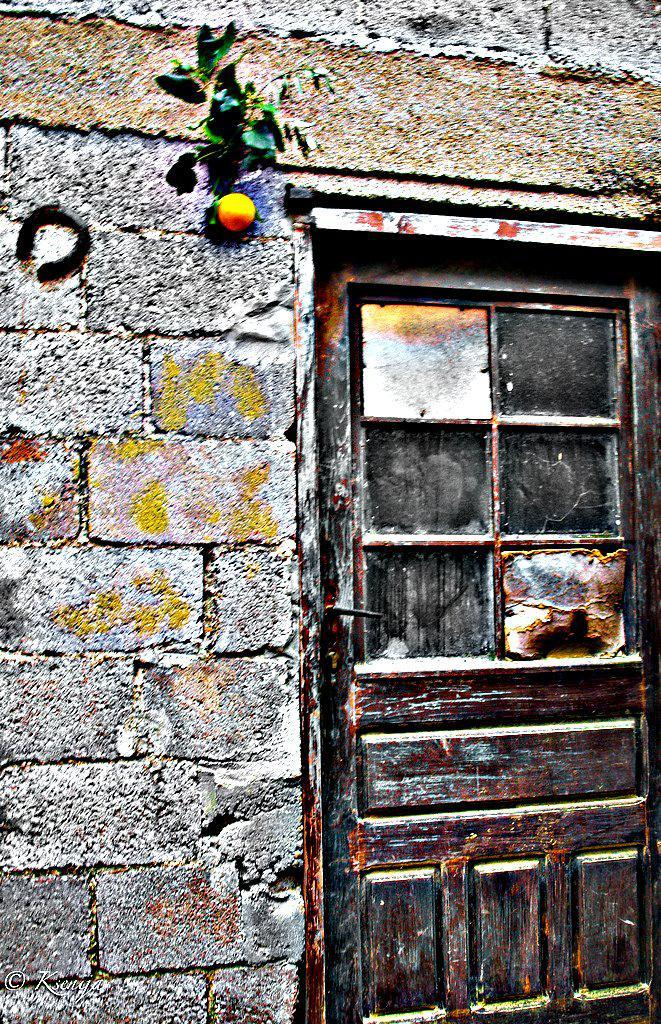What type of door is on the right side of the image? There is a wooden door on the right side of the image. What can be seen in the image besides the door? There are leaves and an object visible in the image. What is the material of the wall in the image? There is a stone wall in the image. What health advice is being given in the image? There is no health advice present in the image. How does the image depict the act of saying good-bye? The image does not depict the act of saying good-bye. 